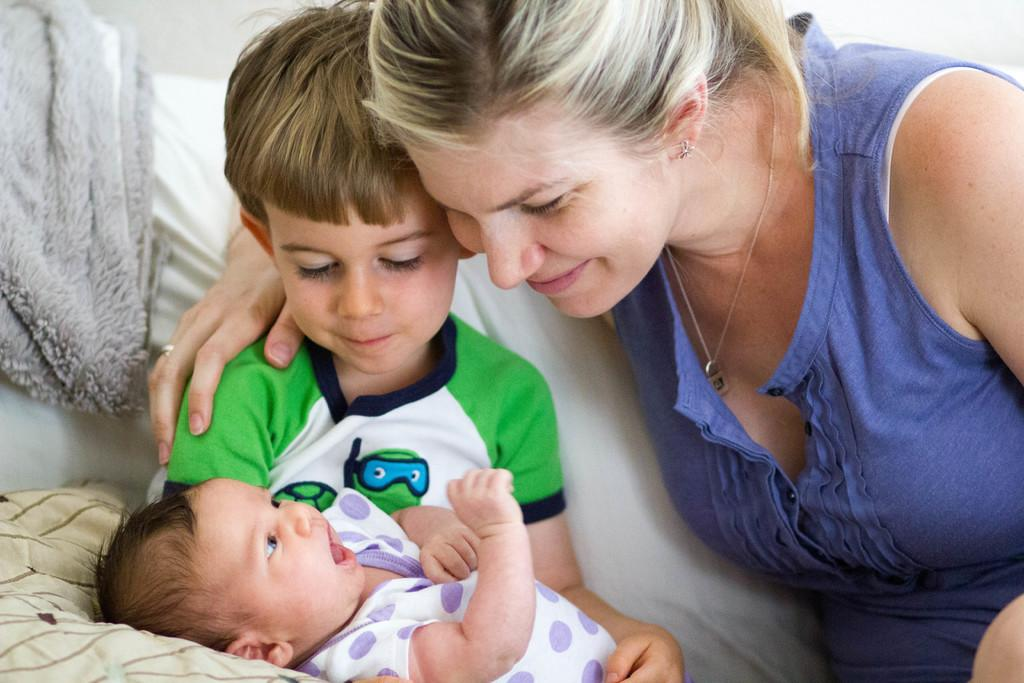Who is present in the image? There is a woman and a boy holding a baby in the image. What is the boy doing with the baby? The boy is holding a baby in the image. What can be seen on the left side of the image? There is a cloth on the left side of the image. What object is located in the bottom left corner of the image? There appears to be a pillow in the bottom left corner of the image. What type of hobbies do the oranges enjoy in the image? There are no oranges present in the image, so it is not possible to determine their hobbies. 